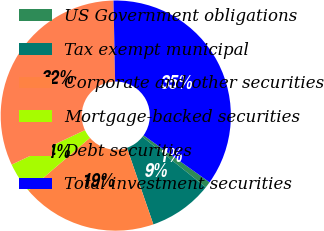<chart> <loc_0><loc_0><loc_500><loc_500><pie_chart><fcel>US Government obligations<fcel>Tax exempt municipal<fcel>Corporate and other securities<fcel>Mortgage-backed securities<fcel>Debt securities<fcel>Total investment securities<nl><fcel>0.86%<fcel>9.01%<fcel>19.0%<fcel>4.29%<fcel>31.69%<fcel>35.15%<nl></chart> 